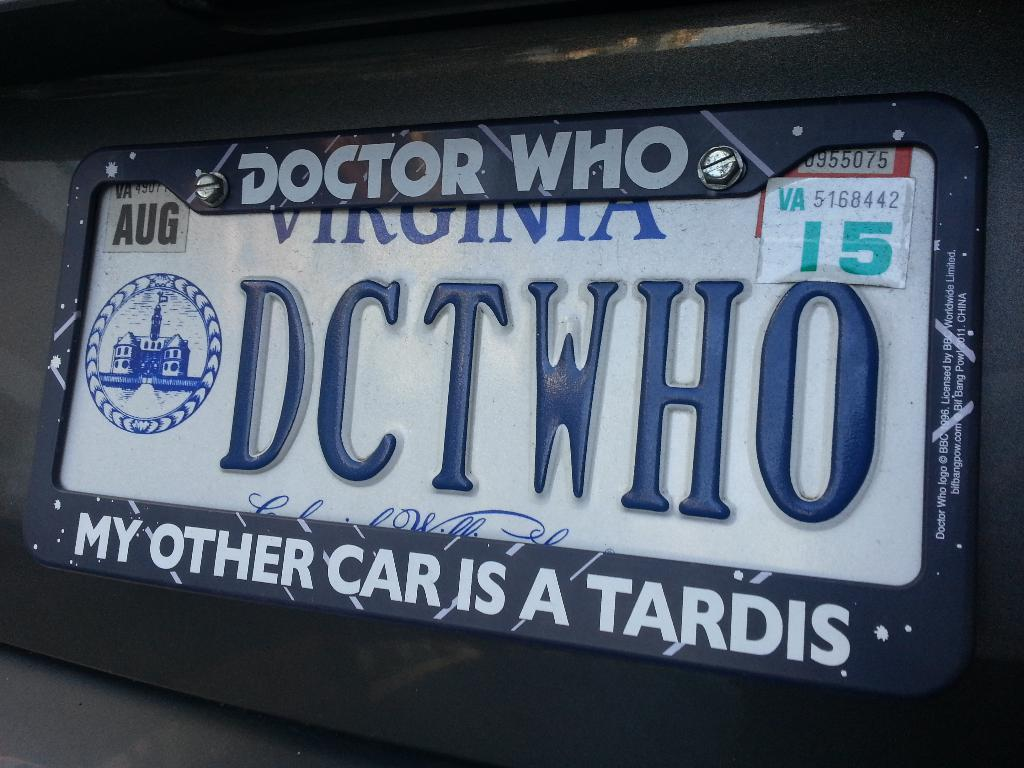<image>
Render a clear and concise summary of the photo. a dctwho sign on the back of a car 